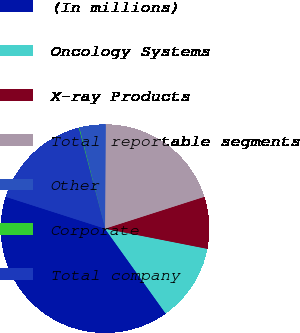Convert chart. <chart><loc_0><loc_0><loc_500><loc_500><pie_chart><fcel>(In millions)<fcel>Oncology Systems<fcel>X-ray Products<fcel>Total reportable segments<fcel>Other<fcel>Corporate<fcel>Total company<nl><fcel>39.82%<fcel>12.02%<fcel>8.04%<fcel>19.96%<fcel>4.07%<fcel>0.1%<fcel>15.99%<nl></chart> 